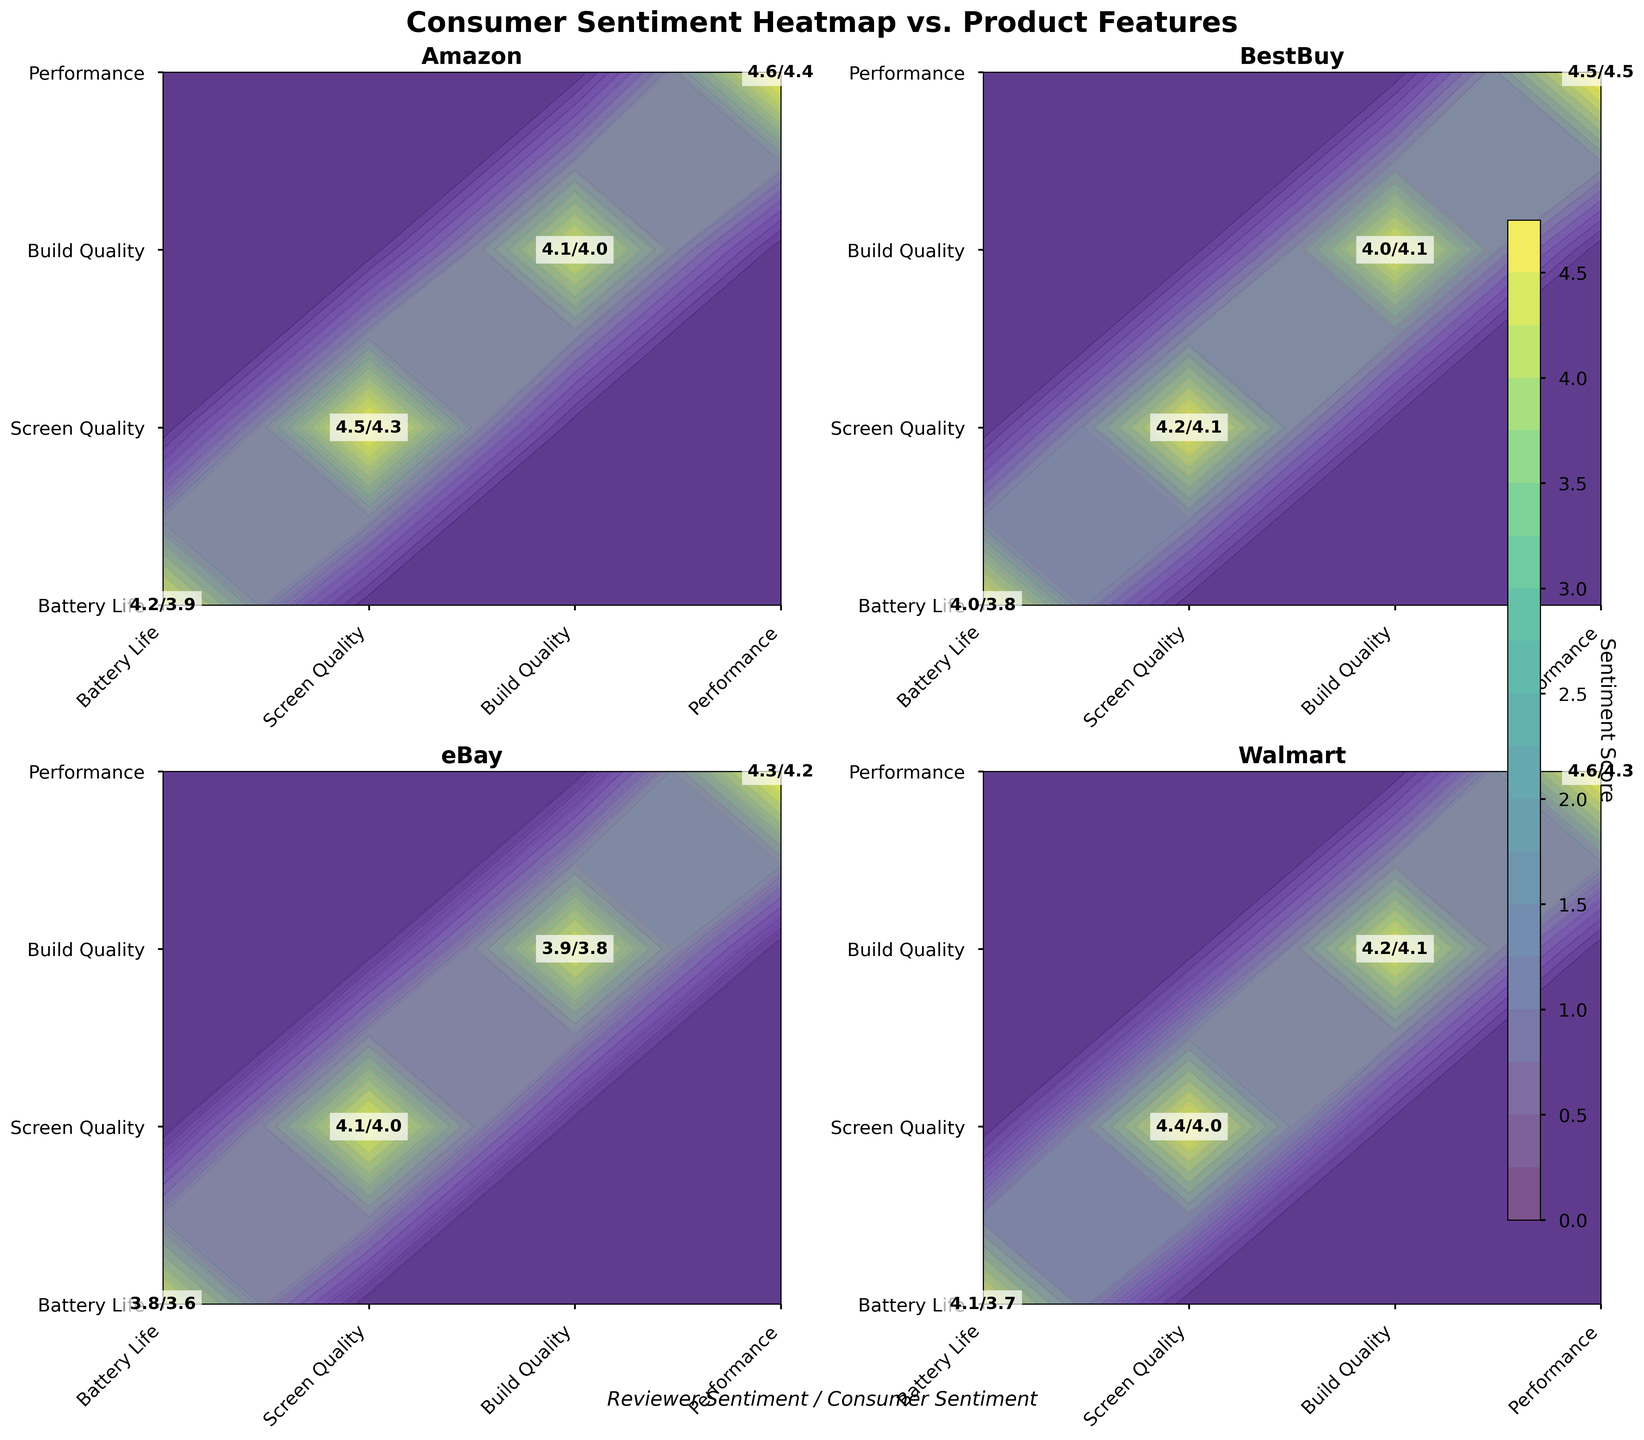What title is given to this figure? The title of the figure is found at the top of the plot and it reads "Consumer Sentiment Heatmap vs. Product Features".
Answer: Consumer Sentiment Heatmap vs. Product Features Which platform's performance feature has the highest consumer sentiment score? The performance feature has its individual plot square, and across all platforms, "Performance" for BestBuy stands out with a consumer sentiment score of 4.5.
Answer: BestBuy What are the sentiment scores for "Battery Life" on Amazon? By looking at Amazon's plot and focusing on the "Battery Life" feature, the reviewer sentiment is 4.2 and the consumer sentiment is 3.9.
Answer: 4.2/3.9 Comparing Amazon's and eBay's "Screen Quality," which has higher reviewer sentiment, and by how much? Amazon's "Screen Quality" reviewer sentiment is 4.5, while eBay's is 4.1. The difference is calculated as 4.5 - 4.1 = 0.4.
Answer: Amazon by 0.4 Which feature has the highest discrepancy between reviewer and consumer sentiments on Walmart? For Walmart, looking at each feature and calculating the differences, "Battery Life" shows the highest discrepancy with reviewer sentiment 4.1 and consumer sentiment 3.7, resulting in a difference of 0.4.
Answer: Battery Life, 0.4 On which platform does "Build Quality" have the lowest consumer sentiment score? Reviewing the consumer sentiment scores for "Build Quality" across all platforms, eBay has the lowest score of 3.8.
Answer: eBay What is the average consumer sentiment for “Performance” across all platforms? To find the average, sum the consumer sentiment scores for “Performance” on all platforms (Amazon: 4.4, BestBuy: 4.5, eBay: 4.2, Walmart: 4.3) and divide by the number of platforms. (4.4 + 4.5 + 4.2 + 4.3) / 4 = 4.35.
Answer: 4.35 Which platform has the closest reviewer and consumer sentiments for “Build Quality”? Evaluating the sentiments for “Build Quality” on all platforms, BestBuy shows almost no discrepancy with reviewer sentiment at 4.0 and consumer sentiment at 4.1, a difference of only 0.1.
Answer: BestBuy Between Amazon and Walmart, which platform shows a greater difference in consumer sentiment for the “Screen Quality” feature? Amazon shows a consumer sentiment of 4.3 for "Screen Quality" and Walmart shows 4.0. The differences from each platform's average sentiment can be calculated, but based on the absolute values, Amazon (4.5 - 4.3 = 0.2) and Walmart (4.4 - 4.0 = 0.4), Walmart shows a greater discrepancy.
Answer: Walmart 